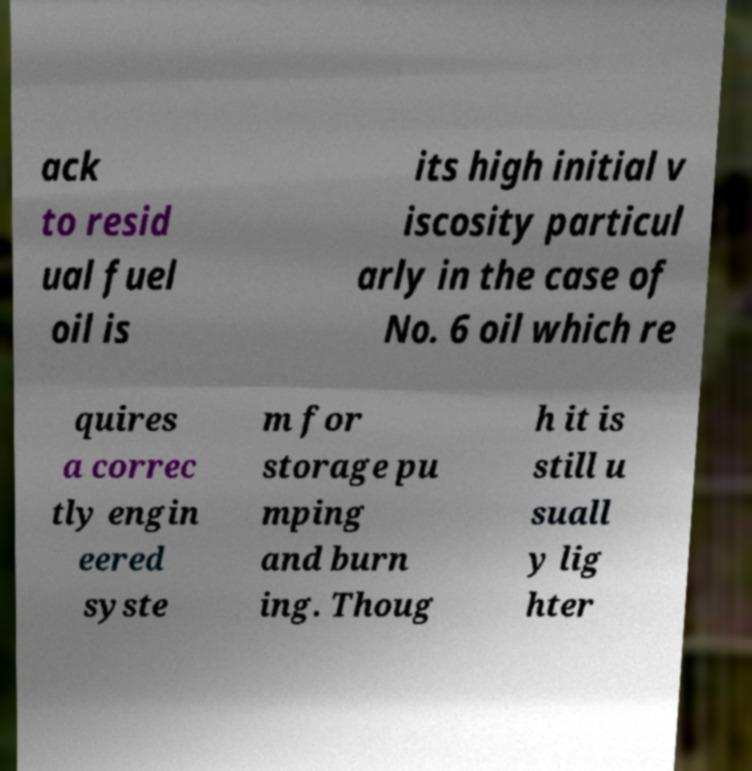Can you accurately transcribe the text from the provided image for me? ack to resid ual fuel oil is its high initial v iscosity particul arly in the case of No. 6 oil which re quires a correc tly engin eered syste m for storage pu mping and burn ing. Thoug h it is still u suall y lig hter 